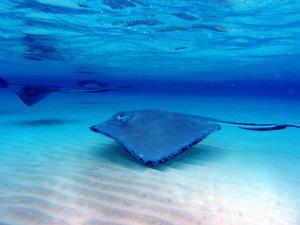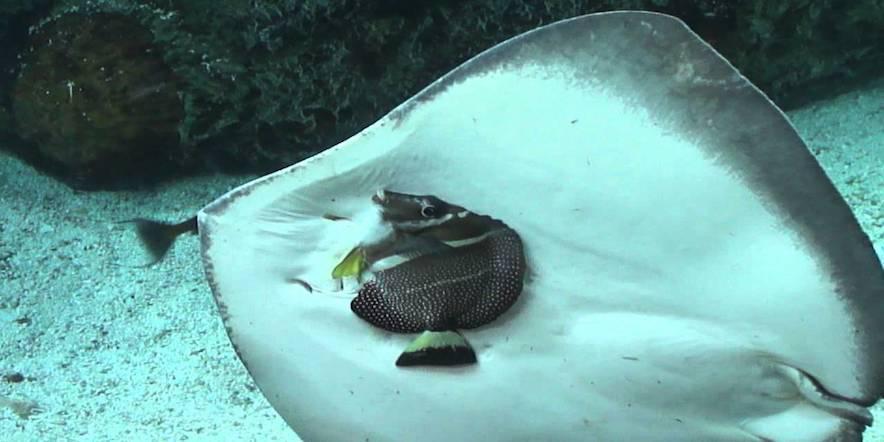The first image is the image on the left, the second image is the image on the right. Assess this claim about the two images: "In exactly one of the images a stingray is eating clams.". Correct or not? Answer yes or no. No. The first image is the image on the left, the second image is the image on the right. Analyze the images presented: Is the assertion "One image appears to show one stingray on top of another stingray, and the other image shows at least one stingray positioned over oyster-like shells." valid? Answer yes or no. No. 